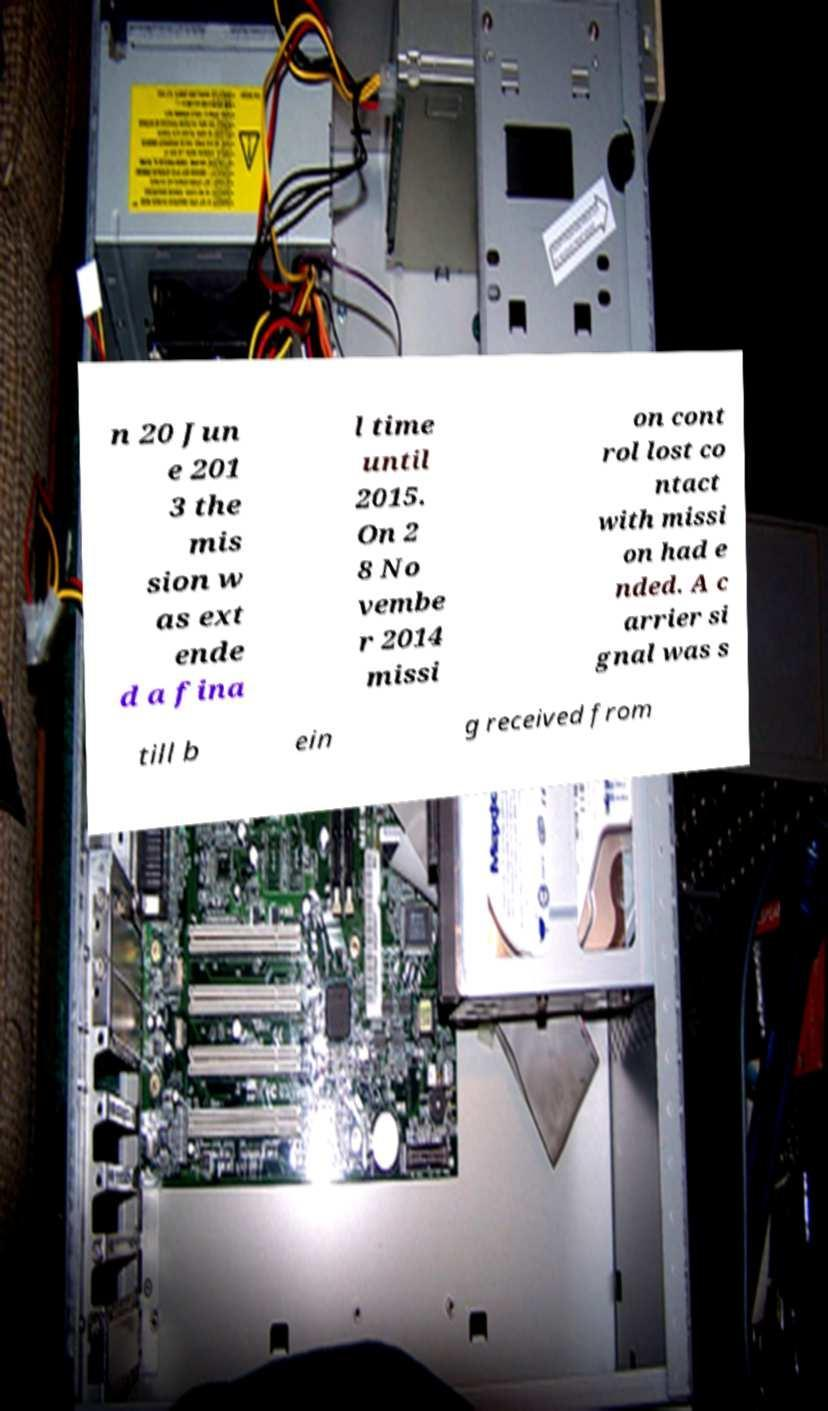Please identify and transcribe the text found in this image. n 20 Jun e 201 3 the mis sion w as ext ende d a fina l time until 2015. On 2 8 No vembe r 2014 missi on cont rol lost co ntact with missi on had e nded. A c arrier si gnal was s till b ein g received from 